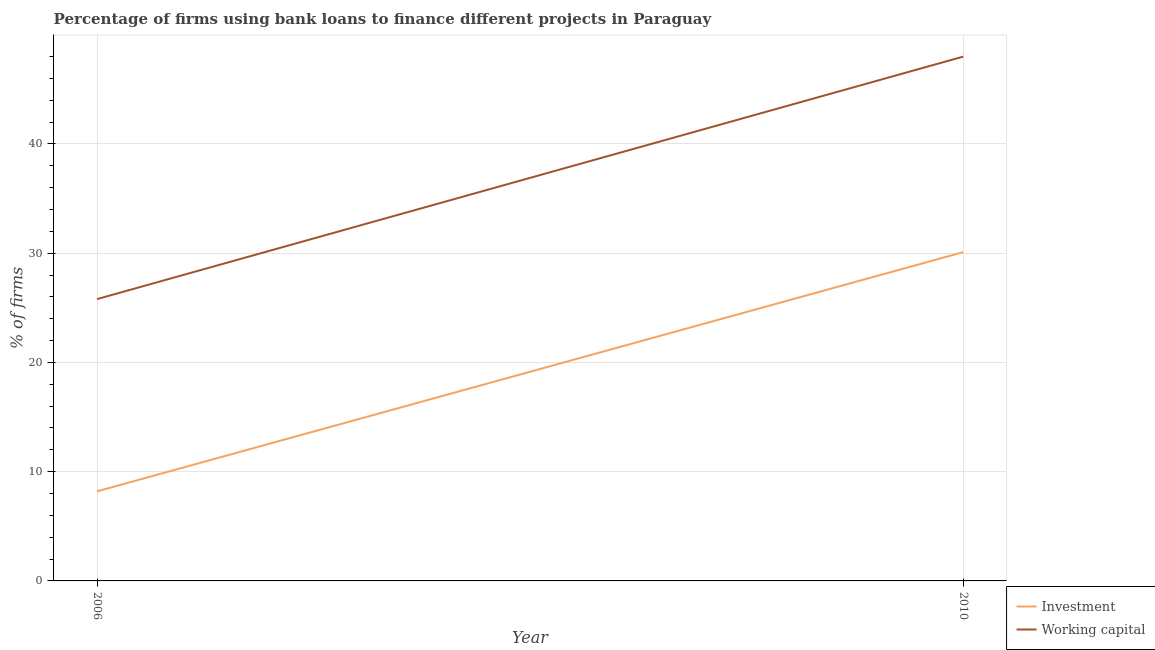How many different coloured lines are there?
Provide a succinct answer. 2. What is the percentage of firms using banks to finance working capital in 2010?
Make the answer very short. 48. Across all years, what is the maximum percentage of firms using banks to finance working capital?
Your answer should be very brief. 48. Across all years, what is the minimum percentage of firms using banks to finance working capital?
Provide a succinct answer. 25.8. In which year was the percentage of firms using banks to finance working capital minimum?
Offer a terse response. 2006. What is the total percentage of firms using banks to finance working capital in the graph?
Offer a terse response. 73.8. What is the difference between the percentage of firms using banks to finance working capital in 2006 and that in 2010?
Ensure brevity in your answer.  -22.2. What is the difference between the percentage of firms using banks to finance investment in 2006 and the percentage of firms using banks to finance working capital in 2010?
Provide a short and direct response. -39.8. What is the average percentage of firms using banks to finance investment per year?
Make the answer very short. 19.15. In the year 2006, what is the difference between the percentage of firms using banks to finance investment and percentage of firms using banks to finance working capital?
Offer a very short reply. -17.6. In how many years, is the percentage of firms using banks to finance working capital greater than 42 %?
Make the answer very short. 1. What is the ratio of the percentage of firms using banks to finance working capital in 2006 to that in 2010?
Make the answer very short. 0.54. Is the percentage of firms using banks to finance investment in 2006 less than that in 2010?
Ensure brevity in your answer.  Yes. In how many years, is the percentage of firms using banks to finance investment greater than the average percentage of firms using banks to finance investment taken over all years?
Provide a short and direct response. 1. Is the percentage of firms using banks to finance working capital strictly greater than the percentage of firms using banks to finance investment over the years?
Offer a very short reply. Yes. How many lines are there?
Keep it short and to the point. 2. How many years are there in the graph?
Your answer should be compact. 2. Are the values on the major ticks of Y-axis written in scientific E-notation?
Your response must be concise. No. Does the graph contain grids?
Provide a short and direct response. Yes. Where does the legend appear in the graph?
Offer a very short reply. Bottom right. How are the legend labels stacked?
Your answer should be very brief. Vertical. What is the title of the graph?
Offer a terse response. Percentage of firms using bank loans to finance different projects in Paraguay. What is the label or title of the X-axis?
Give a very brief answer. Year. What is the label or title of the Y-axis?
Offer a terse response. % of firms. What is the % of firms in Investment in 2006?
Keep it short and to the point. 8.2. What is the % of firms in Working capital in 2006?
Your answer should be very brief. 25.8. What is the % of firms of Investment in 2010?
Ensure brevity in your answer.  30.1. What is the % of firms in Working capital in 2010?
Offer a very short reply. 48. Across all years, what is the maximum % of firms in Investment?
Keep it short and to the point. 30.1. Across all years, what is the minimum % of firms of Investment?
Your answer should be compact. 8.2. Across all years, what is the minimum % of firms of Working capital?
Offer a very short reply. 25.8. What is the total % of firms in Investment in the graph?
Your response must be concise. 38.3. What is the total % of firms in Working capital in the graph?
Your answer should be compact. 73.8. What is the difference between the % of firms of Investment in 2006 and that in 2010?
Keep it short and to the point. -21.9. What is the difference between the % of firms in Working capital in 2006 and that in 2010?
Offer a terse response. -22.2. What is the difference between the % of firms in Investment in 2006 and the % of firms in Working capital in 2010?
Ensure brevity in your answer.  -39.8. What is the average % of firms in Investment per year?
Offer a terse response. 19.15. What is the average % of firms of Working capital per year?
Make the answer very short. 36.9. In the year 2006, what is the difference between the % of firms in Investment and % of firms in Working capital?
Your response must be concise. -17.6. In the year 2010, what is the difference between the % of firms in Investment and % of firms in Working capital?
Make the answer very short. -17.9. What is the ratio of the % of firms in Investment in 2006 to that in 2010?
Offer a terse response. 0.27. What is the ratio of the % of firms of Working capital in 2006 to that in 2010?
Your response must be concise. 0.54. What is the difference between the highest and the second highest % of firms in Investment?
Your response must be concise. 21.9. What is the difference between the highest and the second highest % of firms of Working capital?
Provide a short and direct response. 22.2. What is the difference between the highest and the lowest % of firms in Investment?
Offer a terse response. 21.9. What is the difference between the highest and the lowest % of firms in Working capital?
Your answer should be compact. 22.2. 